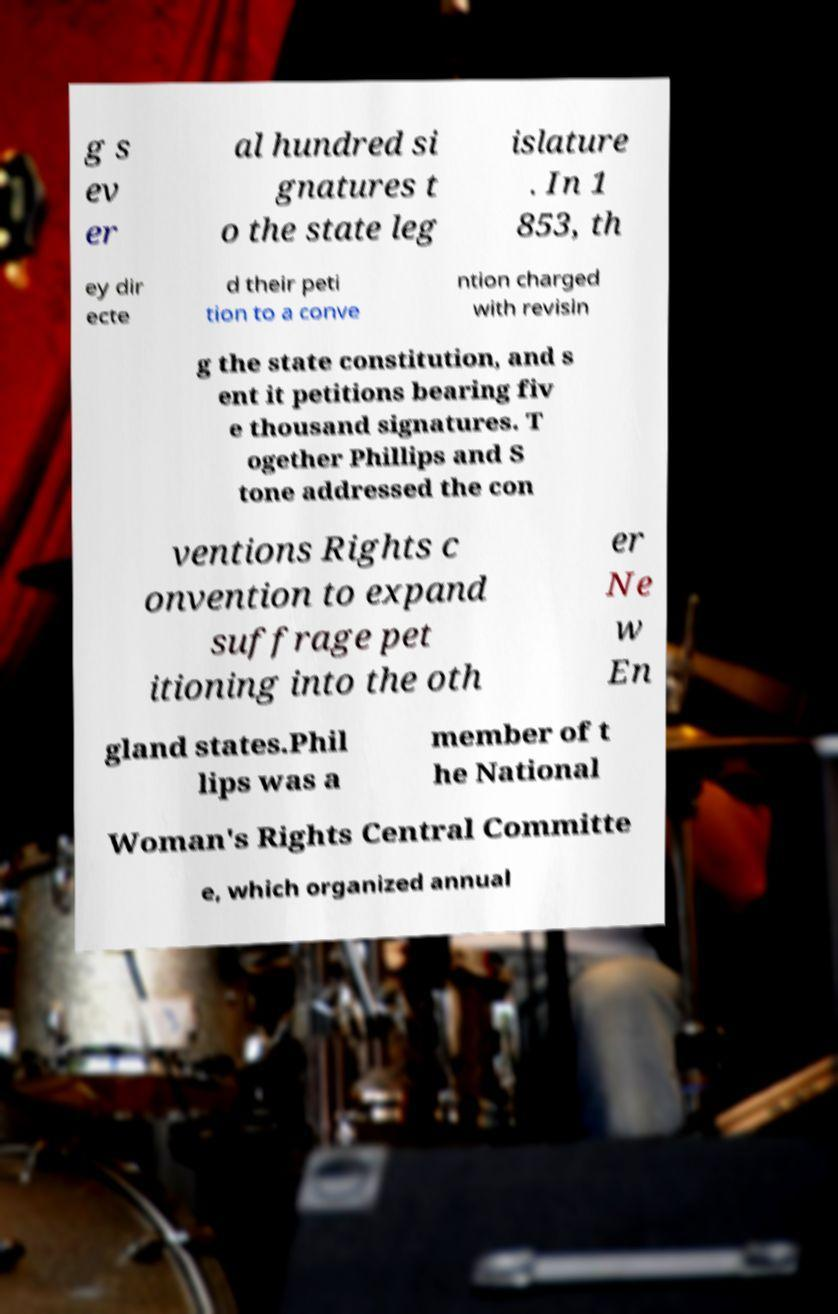Can you accurately transcribe the text from the provided image for me? g s ev er al hundred si gnatures t o the state leg islature . In 1 853, th ey dir ecte d their peti tion to a conve ntion charged with revisin g the state constitution, and s ent it petitions bearing fiv e thousand signatures. T ogether Phillips and S tone addressed the con ventions Rights c onvention to expand suffrage pet itioning into the oth er Ne w En gland states.Phil lips was a member of t he National Woman's Rights Central Committe e, which organized annual 